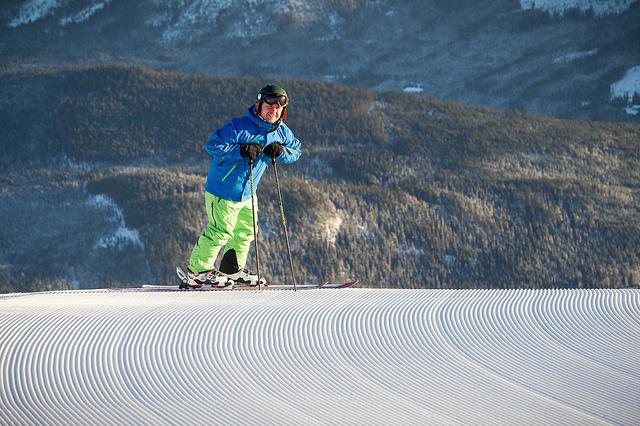What color are the stripes on the skiers pants?
Answer briefly. Black. What is the person holding?
Give a very brief answer. Ski poles. Is the skier in motion?
Short answer required. Yes. 